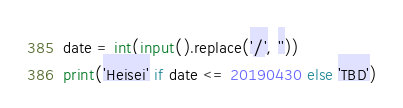Convert code to text. <code><loc_0><loc_0><loc_500><loc_500><_Python_>date = int(input().replace('/', ''))
print('Heisei' if date <= 20190430 else 'TBD')
</code> 